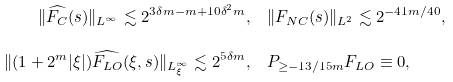<formula> <loc_0><loc_0><loc_500><loc_500>\| \widehat { F _ { C } } ( s ) \| _ { L ^ { \infty } } \lesssim 2 ^ { 3 \delta m - m + 1 0 \delta ^ { 2 } m } , & \quad \| F _ { N C } ( s ) \| _ { L ^ { 2 } } \lesssim 2 ^ { - 4 1 m / 4 0 } , \\ \| ( 1 + 2 ^ { m } | \xi | ) \widehat { F _ { L O } } ( \xi , s ) \| _ { L ^ { \infty } _ { \xi } } \lesssim 2 ^ { 5 \delta m } , & \quad P _ { \geq - 1 3 / 1 5 m } F _ { L O } \equiv 0 ,</formula> 